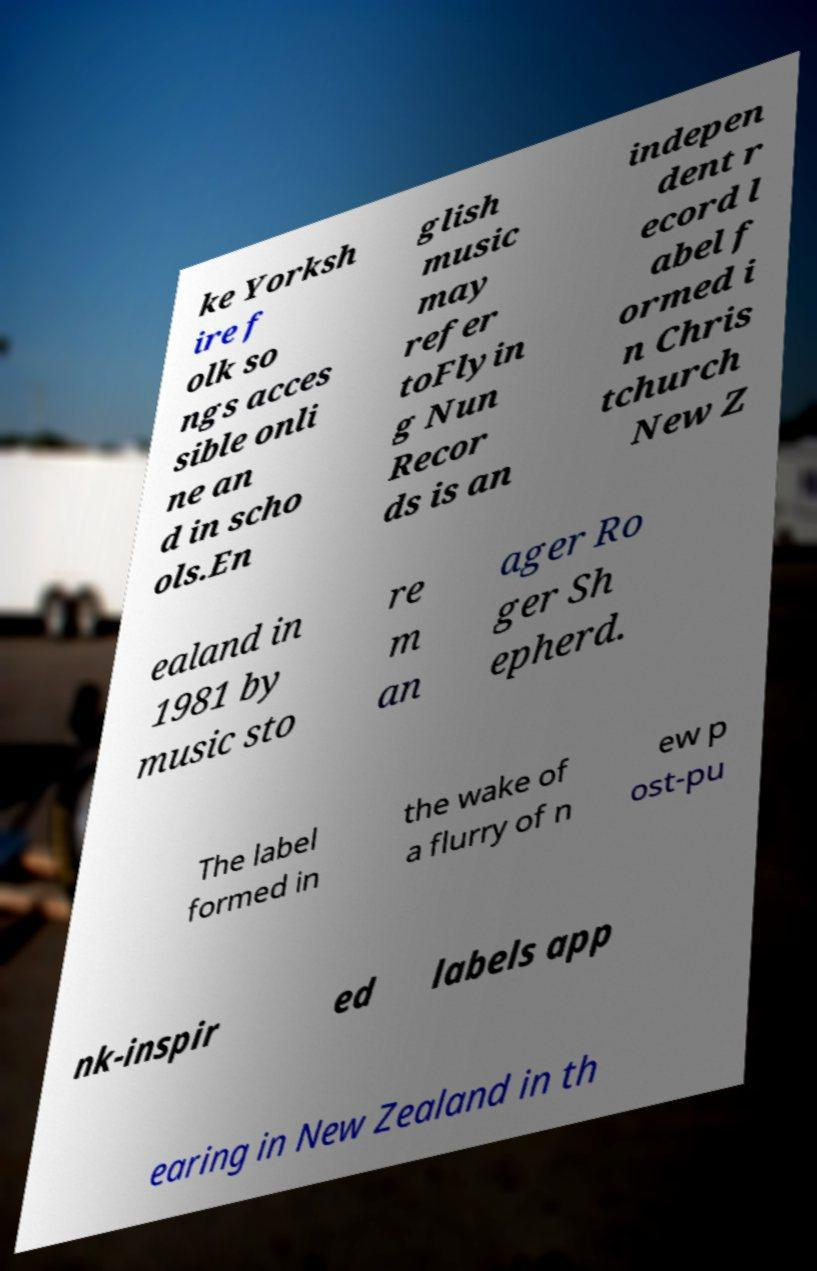Please identify and transcribe the text found in this image. ke Yorksh ire f olk so ngs acces sible onli ne an d in scho ols.En glish music may refer toFlyin g Nun Recor ds is an indepen dent r ecord l abel f ormed i n Chris tchurch New Z ealand in 1981 by music sto re m an ager Ro ger Sh epherd. The label formed in the wake of a flurry of n ew p ost-pu nk-inspir ed labels app earing in New Zealand in th 